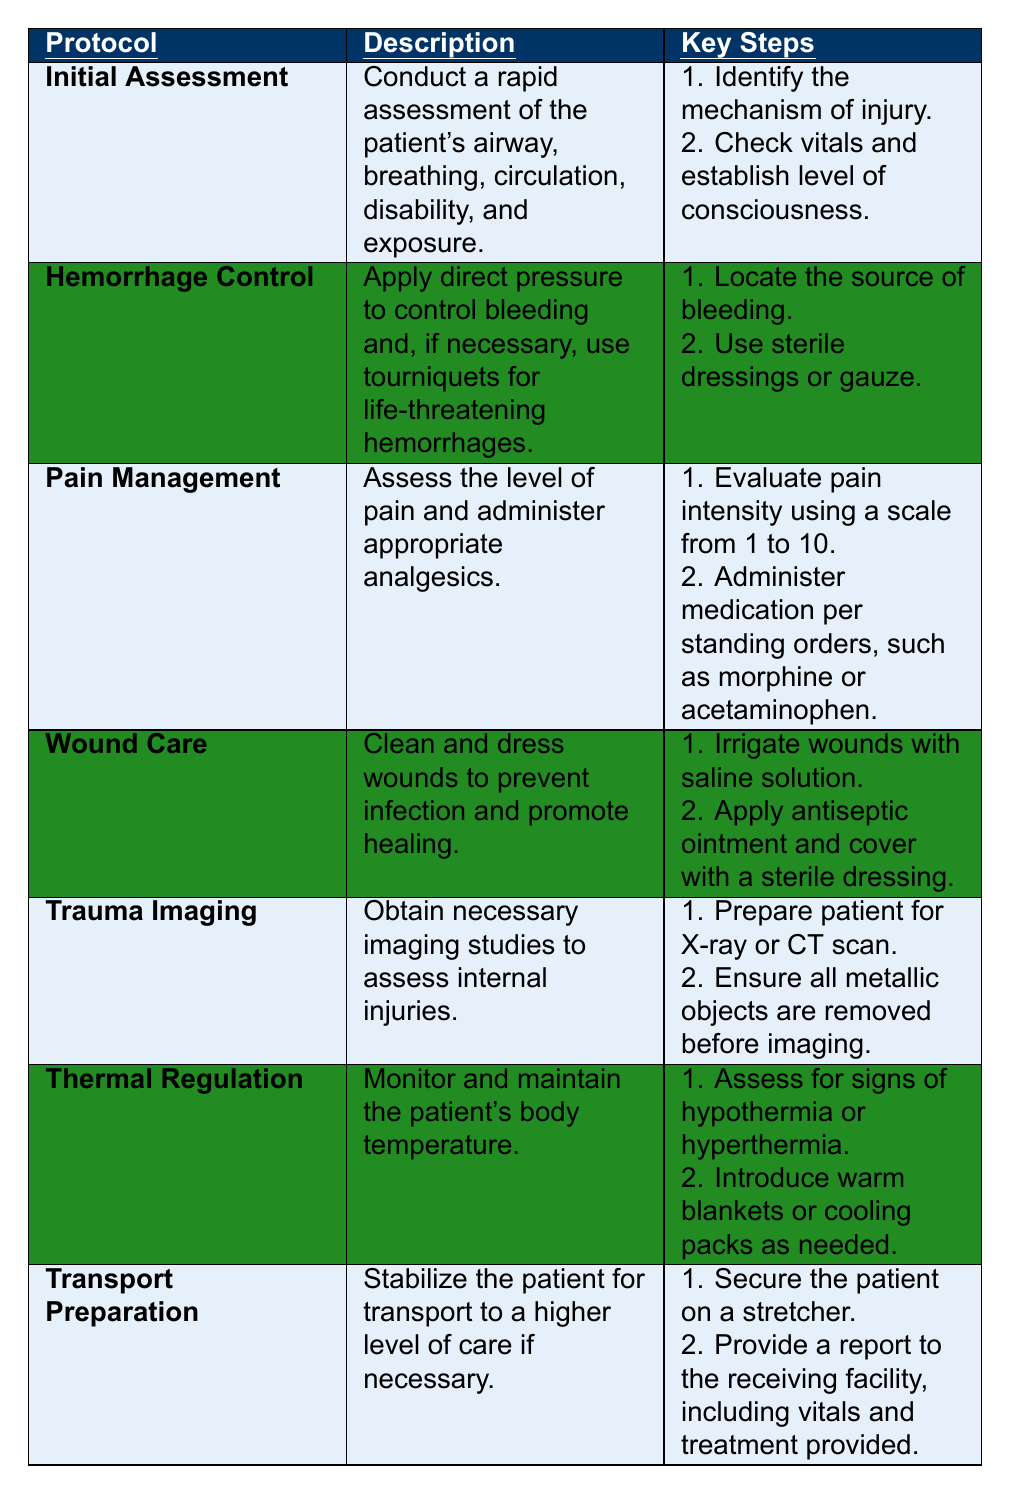What is the purpose of the "Initial Assessment" protocol? The "Initial Assessment" protocol involves conducting a rapid assessment of the patient's vital functions, including airway, breathing, circulation, disability, and exposure. This helps ensure that immediate threats to life are identified and addressed.
Answer: Rapid assessment of vital functions What are the key steps for "Hemorrhage Control"? The key steps for "Hemorrhage Control" include locating the source of bleeding and using sterile dressings or gauze to control it. These steps are essential to manage potentially life-threatening bleedings properly.
Answer: Locate source and use dressings Does "Wound Care" include applying antiseptic ointment? Yes, "Wound Care" involves cleaning and dressing wounds, which includes applying antiseptic ointment to help prevent infection.
Answer: Yes How many treatment protocols are listed in the table? There are seven treatment protocols listed in the table.
Answer: Seven What protocol should be used to manage severe bleeding? The "Hemorrhage Control" protocol is used to manage severe bleeding as it specifically addresses applying direct pressure and using tourniquets if necessary.
Answer: Hemorrhage Control What steps are involved in "Pain Management"? The steps involved in "Pain Management" are evaluating pain intensity using a scale from 1 to 10 and administering medication per standing orders, such as morphine or acetaminophen.
Answer: Evaluate pain and administer medication Is the "Transport Preparation" protocol necessary for all patients? No, the "Transport Preparation" protocol is only necessary for patients who require stabilization for transport to a higher level of care.
Answer: No Which protocol involves preparing a patient for an imaging study like X-ray? The "Trauma Imaging" protocol involves preparing a patient for imaging studies such as X-rays or CT scans to assess internal injuries.
Answer: Trauma Imaging What are the two steps involved in "Thermal Regulation"? The two steps involved in "Thermal Regulation" are assessing for signs of hypothermia or hyperthermia and introducing warm blankets or cooling packs as needed to maintain the patient's body temperature.
Answer: Assess temperature signs and introduce blankets or packs If a patient is stabilized for transport, which protocol applies? The "Transport Preparation" protocol applies when a patient is stabilized for transport to ensure they are secure and an appropriate report is provided to the receiving facility.
Answer: Transport Preparation What is the first step in "Wound Care"? The first step in "Wound Care" is to irrigate wounds with saline solution, which helps clean the wound before dressing it.
Answer: Irrigate with saline solution 